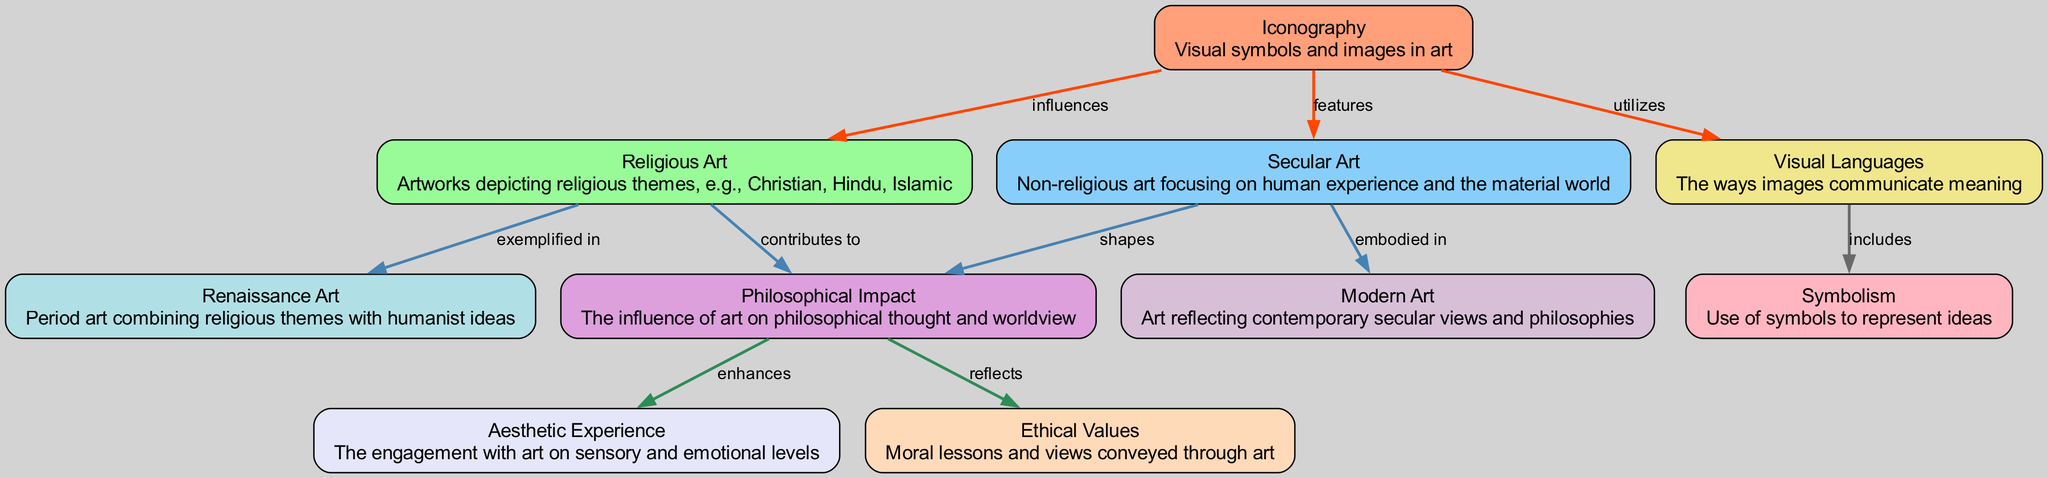What is depicted in the node labeled 'Iconography'? The node 'Iconography' describes visual symbols and images used in art, indicating its role as a foundational element in both religious and secular art contexts.
Answer: Visual symbols and images in art How many nodes are present in the diagram? Counting all the distinct entities represented, there are ten nodes in the diagram, including 'Iconography', 'Religious Art', 'Secular Art', and others.
Answer: 10 What is the relationship between 'Religious Art' and 'Philosophical Impact'? The edge connecting 'Religious Art' to 'Philosophical Impact' is labeled 'contributes to', indicating that religious art plays a role in shaping philosophical thought.
Answer: contributes to Which types of art are linked to 'Modern Art'? 'Modern Art' is directly connected to 'Secular Art' through the edge labeled 'embodied in', indicating that modern art represents or encompasses secular artistic expressions.
Answer: Secular Art How do 'Visual Languages' and 'Symbolism' relate to each other? 'Visual Languages' leads to 'Symbolism' through an edge labeled 'includes', meaning visual communication methods encompass the use of symbols.
Answer: includes Why does 'Philosophical Impact' enhance 'Aesthetic Experience'? The diagram shows a direct relationship labeled 'enhances', suggesting that the philosophical consequences of art contribute positively to the sensory enjoyment derived from engaging with art.
Answer: enhances Which two types of art are exemplified in 'Renaissance Art'? The diagram indicates two forms of art contributing to 'Renaissance Art'– 'Religious Art' and 'Secular Art', where both religious themes and humanistic ideas merge during that period.
Answer: Religious Art, Secular Art What ethical aspect does the 'Philosophical Impact' reflect? The edge labeled 'reflects' indicates that 'Philosophical Impact' embodies or represents the moral lessons and views conveyed through the various forms of art.
Answer: Ethical Values What primary element does 'Iconography' utilize in conveying meaning? The relationship labeled 'utilizes' shows that 'Iconography' employs visual languages to communicate artistic ideas effectively.
Answer: Visual Languages 